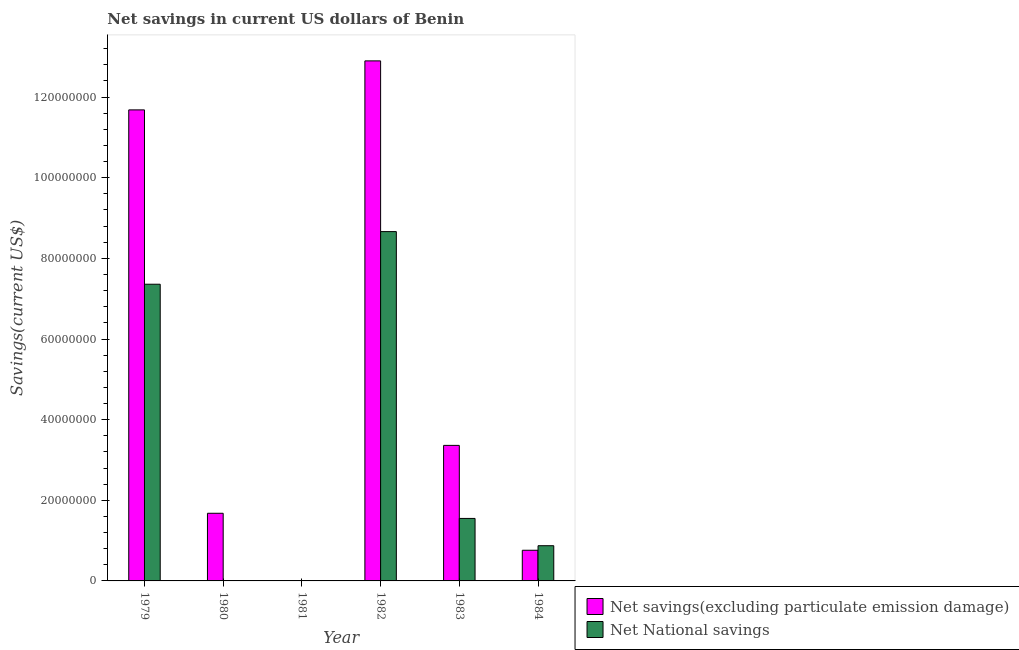How many different coloured bars are there?
Your answer should be very brief. 2. Are the number of bars per tick equal to the number of legend labels?
Keep it short and to the point. No. What is the label of the 2nd group of bars from the left?
Make the answer very short. 1980. What is the net national savings in 1984?
Provide a succinct answer. 8.73e+06. Across all years, what is the maximum net national savings?
Keep it short and to the point. 8.66e+07. Across all years, what is the minimum net savings(excluding particulate emission damage)?
Provide a succinct answer. 0. What is the total net national savings in the graph?
Offer a terse response. 1.84e+08. What is the difference between the net savings(excluding particulate emission damage) in 1983 and that in 1984?
Make the answer very short. 2.60e+07. What is the difference between the net savings(excluding particulate emission damage) in 1980 and the net national savings in 1983?
Your answer should be very brief. -1.68e+07. What is the average net national savings per year?
Ensure brevity in your answer.  3.07e+07. In how many years, is the net savings(excluding particulate emission damage) greater than 72000000 US$?
Your answer should be compact. 2. What is the ratio of the net national savings in 1979 to that in 1984?
Your answer should be compact. 8.43. What is the difference between the highest and the second highest net savings(excluding particulate emission damage)?
Ensure brevity in your answer.  1.22e+07. What is the difference between the highest and the lowest net national savings?
Your answer should be very brief. 8.66e+07. How many bars are there?
Make the answer very short. 9. Are all the bars in the graph horizontal?
Make the answer very short. No. How many years are there in the graph?
Offer a very short reply. 6. What is the difference between two consecutive major ticks on the Y-axis?
Provide a succinct answer. 2.00e+07. Does the graph contain grids?
Your answer should be compact. No. How are the legend labels stacked?
Your response must be concise. Vertical. What is the title of the graph?
Ensure brevity in your answer.  Net savings in current US dollars of Benin. What is the label or title of the X-axis?
Make the answer very short. Year. What is the label or title of the Y-axis?
Your response must be concise. Savings(current US$). What is the Savings(current US$) in Net savings(excluding particulate emission damage) in 1979?
Provide a succinct answer. 1.17e+08. What is the Savings(current US$) of Net National savings in 1979?
Provide a succinct answer. 7.36e+07. What is the Savings(current US$) of Net savings(excluding particulate emission damage) in 1980?
Offer a terse response. 1.68e+07. What is the Savings(current US$) of Net National savings in 1980?
Your answer should be very brief. 0. What is the Savings(current US$) of Net savings(excluding particulate emission damage) in 1982?
Ensure brevity in your answer.  1.29e+08. What is the Savings(current US$) of Net National savings in 1982?
Your response must be concise. 8.66e+07. What is the Savings(current US$) of Net savings(excluding particulate emission damage) in 1983?
Offer a very short reply. 3.36e+07. What is the Savings(current US$) of Net National savings in 1983?
Give a very brief answer. 1.55e+07. What is the Savings(current US$) in Net savings(excluding particulate emission damage) in 1984?
Give a very brief answer. 7.60e+06. What is the Savings(current US$) of Net National savings in 1984?
Keep it short and to the point. 8.73e+06. Across all years, what is the maximum Savings(current US$) of Net savings(excluding particulate emission damage)?
Offer a very short reply. 1.29e+08. Across all years, what is the maximum Savings(current US$) in Net National savings?
Make the answer very short. 8.66e+07. Across all years, what is the minimum Savings(current US$) of Net savings(excluding particulate emission damage)?
Keep it short and to the point. 0. What is the total Savings(current US$) of Net savings(excluding particulate emission damage) in the graph?
Keep it short and to the point. 3.04e+08. What is the total Savings(current US$) of Net National savings in the graph?
Your answer should be compact. 1.84e+08. What is the difference between the Savings(current US$) of Net savings(excluding particulate emission damage) in 1979 and that in 1980?
Provide a succinct answer. 1.00e+08. What is the difference between the Savings(current US$) in Net savings(excluding particulate emission damage) in 1979 and that in 1982?
Keep it short and to the point. -1.22e+07. What is the difference between the Savings(current US$) in Net National savings in 1979 and that in 1982?
Ensure brevity in your answer.  -1.31e+07. What is the difference between the Savings(current US$) in Net savings(excluding particulate emission damage) in 1979 and that in 1983?
Give a very brief answer. 8.32e+07. What is the difference between the Savings(current US$) in Net National savings in 1979 and that in 1983?
Give a very brief answer. 5.81e+07. What is the difference between the Savings(current US$) in Net savings(excluding particulate emission damage) in 1979 and that in 1984?
Give a very brief answer. 1.09e+08. What is the difference between the Savings(current US$) in Net National savings in 1979 and that in 1984?
Your answer should be very brief. 6.49e+07. What is the difference between the Savings(current US$) in Net savings(excluding particulate emission damage) in 1980 and that in 1982?
Your answer should be very brief. -1.12e+08. What is the difference between the Savings(current US$) in Net savings(excluding particulate emission damage) in 1980 and that in 1983?
Your answer should be compact. -1.68e+07. What is the difference between the Savings(current US$) of Net savings(excluding particulate emission damage) in 1980 and that in 1984?
Give a very brief answer. 9.18e+06. What is the difference between the Savings(current US$) of Net savings(excluding particulate emission damage) in 1982 and that in 1983?
Your answer should be very brief. 9.54e+07. What is the difference between the Savings(current US$) of Net National savings in 1982 and that in 1983?
Provide a succinct answer. 7.11e+07. What is the difference between the Savings(current US$) in Net savings(excluding particulate emission damage) in 1982 and that in 1984?
Offer a terse response. 1.21e+08. What is the difference between the Savings(current US$) in Net National savings in 1982 and that in 1984?
Make the answer very short. 7.79e+07. What is the difference between the Savings(current US$) in Net savings(excluding particulate emission damage) in 1983 and that in 1984?
Your response must be concise. 2.60e+07. What is the difference between the Savings(current US$) of Net National savings in 1983 and that in 1984?
Ensure brevity in your answer.  6.77e+06. What is the difference between the Savings(current US$) of Net savings(excluding particulate emission damage) in 1979 and the Savings(current US$) of Net National savings in 1982?
Ensure brevity in your answer.  3.02e+07. What is the difference between the Savings(current US$) of Net savings(excluding particulate emission damage) in 1979 and the Savings(current US$) of Net National savings in 1983?
Offer a very short reply. 1.01e+08. What is the difference between the Savings(current US$) of Net savings(excluding particulate emission damage) in 1979 and the Savings(current US$) of Net National savings in 1984?
Offer a very short reply. 1.08e+08. What is the difference between the Savings(current US$) in Net savings(excluding particulate emission damage) in 1980 and the Savings(current US$) in Net National savings in 1982?
Your answer should be compact. -6.99e+07. What is the difference between the Savings(current US$) of Net savings(excluding particulate emission damage) in 1980 and the Savings(current US$) of Net National savings in 1983?
Offer a terse response. 1.28e+06. What is the difference between the Savings(current US$) in Net savings(excluding particulate emission damage) in 1980 and the Savings(current US$) in Net National savings in 1984?
Your response must be concise. 8.05e+06. What is the difference between the Savings(current US$) of Net savings(excluding particulate emission damage) in 1982 and the Savings(current US$) of Net National savings in 1983?
Provide a succinct answer. 1.13e+08. What is the difference between the Savings(current US$) of Net savings(excluding particulate emission damage) in 1982 and the Savings(current US$) of Net National savings in 1984?
Provide a short and direct response. 1.20e+08. What is the difference between the Savings(current US$) of Net savings(excluding particulate emission damage) in 1983 and the Savings(current US$) of Net National savings in 1984?
Your response must be concise. 2.49e+07. What is the average Savings(current US$) of Net savings(excluding particulate emission damage) per year?
Offer a very short reply. 5.06e+07. What is the average Savings(current US$) of Net National savings per year?
Make the answer very short. 3.07e+07. In the year 1979, what is the difference between the Savings(current US$) of Net savings(excluding particulate emission damage) and Savings(current US$) of Net National savings?
Provide a succinct answer. 4.32e+07. In the year 1982, what is the difference between the Savings(current US$) in Net savings(excluding particulate emission damage) and Savings(current US$) in Net National savings?
Keep it short and to the point. 4.23e+07. In the year 1983, what is the difference between the Savings(current US$) of Net savings(excluding particulate emission damage) and Savings(current US$) of Net National savings?
Offer a terse response. 1.81e+07. In the year 1984, what is the difference between the Savings(current US$) of Net savings(excluding particulate emission damage) and Savings(current US$) of Net National savings?
Provide a succinct answer. -1.13e+06. What is the ratio of the Savings(current US$) of Net savings(excluding particulate emission damage) in 1979 to that in 1980?
Provide a succinct answer. 6.96. What is the ratio of the Savings(current US$) of Net savings(excluding particulate emission damage) in 1979 to that in 1982?
Your response must be concise. 0.91. What is the ratio of the Savings(current US$) of Net National savings in 1979 to that in 1982?
Your answer should be compact. 0.85. What is the ratio of the Savings(current US$) in Net savings(excluding particulate emission damage) in 1979 to that in 1983?
Offer a very short reply. 3.48. What is the ratio of the Savings(current US$) in Net National savings in 1979 to that in 1983?
Offer a terse response. 4.75. What is the ratio of the Savings(current US$) of Net savings(excluding particulate emission damage) in 1979 to that in 1984?
Make the answer very short. 15.37. What is the ratio of the Savings(current US$) in Net National savings in 1979 to that in 1984?
Keep it short and to the point. 8.43. What is the ratio of the Savings(current US$) in Net savings(excluding particulate emission damage) in 1980 to that in 1982?
Provide a succinct answer. 0.13. What is the ratio of the Savings(current US$) of Net savings(excluding particulate emission damage) in 1980 to that in 1983?
Your answer should be very brief. 0.5. What is the ratio of the Savings(current US$) of Net savings(excluding particulate emission damage) in 1980 to that in 1984?
Your response must be concise. 2.21. What is the ratio of the Savings(current US$) in Net savings(excluding particulate emission damage) in 1982 to that in 1983?
Your response must be concise. 3.84. What is the ratio of the Savings(current US$) of Net National savings in 1982 to that in 1983?
Provide a short and direct response. 5.59. What is the ratio of the Savings(current US$) in Net savings(excluding particulate emission damage) in 1982 to that in 1984?
Offer a terse response. 16.96. What is the ratio of the Savings(current US$) in Net National savings in 1982 to that in 1984?
Your answer should be very brief. 9.92. What is the ratio of the Savings(current US$) in Net savings(excluding particulate emission damage) in 1983 to that in 1984?
Offer a terse response. 4.42. What is the ratio of the Savings(current US$) of Net National savings in 1983 to that in 1984?
Offer a terse response. 1.77. What is the difference between the highest and the second highest Savings(current US$) of Net savings(excluding particulate emission damage)?
Offer a very short reply. 1.22e+07. What is the difference between the highest and the second highest Savings(current US$) in Net National savings?
Make the answer very short. 1.31e+07. What is the difference between the highest and the lowest Savings(current US$) of Net savings(excluding particulate emission damage)?
Ensure brevity in your answer.  1.29e+08. What is the difference between the highest and the lowest Savings(current US$) in Net National savings?
Offer a very short reply. 8.66e+07. 